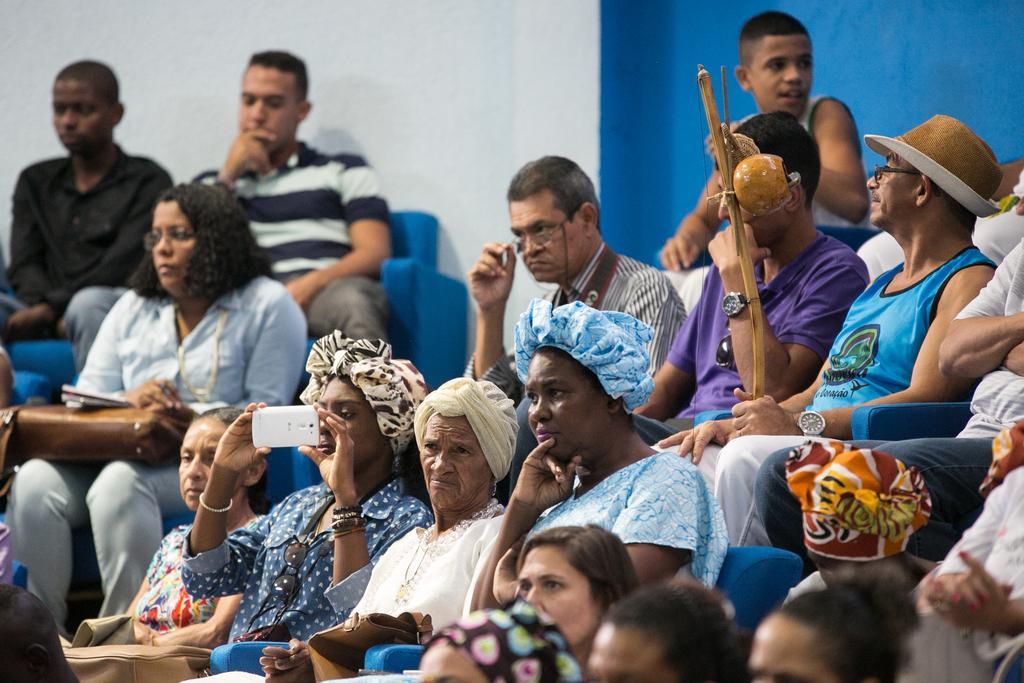Describe this image in one or two sentences. In this image there are persons sitting on a blue colour chair. The woman in the center is holding a mobile phone in her hand and clicking a photo and the man on the right side is sitting and holding a stick in his hand wearing a brown colour hat. In the background there is a wall which is white and blue in colour. 